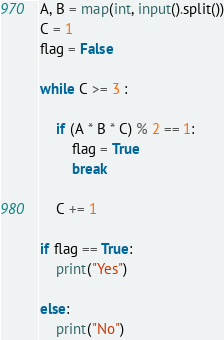Convert code to text. <code><loc_0><loc_0><loc_500><loc_500><_Python_>A, B = map(int, input().split())
C = 1
flag = False

while C >= 3 :

    if (A * B * C) % 2 == 1:
        flag = True
        break
    
    C += 1

if flag == True:
    print("Yes")

else:
    print("No")</code> 